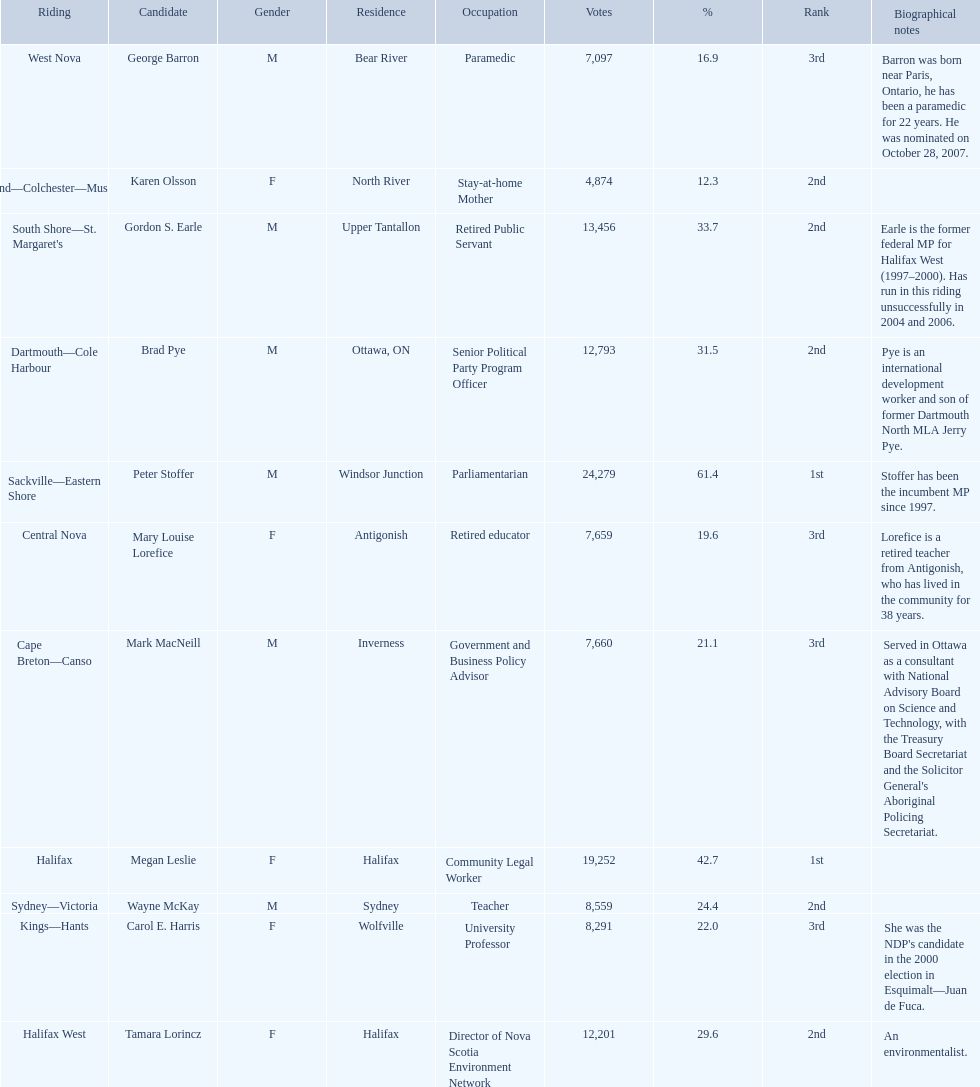Tell me the total number of votes the female candidates got. 52,277. 